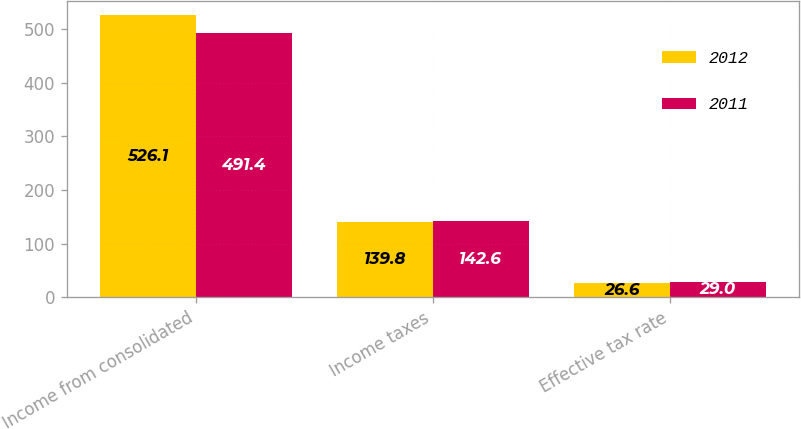Convert chart to OTSL. <chart><loc_0><loc_0><loc_500><loc_500><stacked_bar_chart><ecel><fcel>Income from consolidated<fcel>Income taxes<fcel>Effective tax rate<nl><fcel>2012<fcel>526.1<fcel>139.8<fcel>26.6<nl><fcel>2011<fcel>491.4<fcel>142.6<fcel>29<nl></chart> 